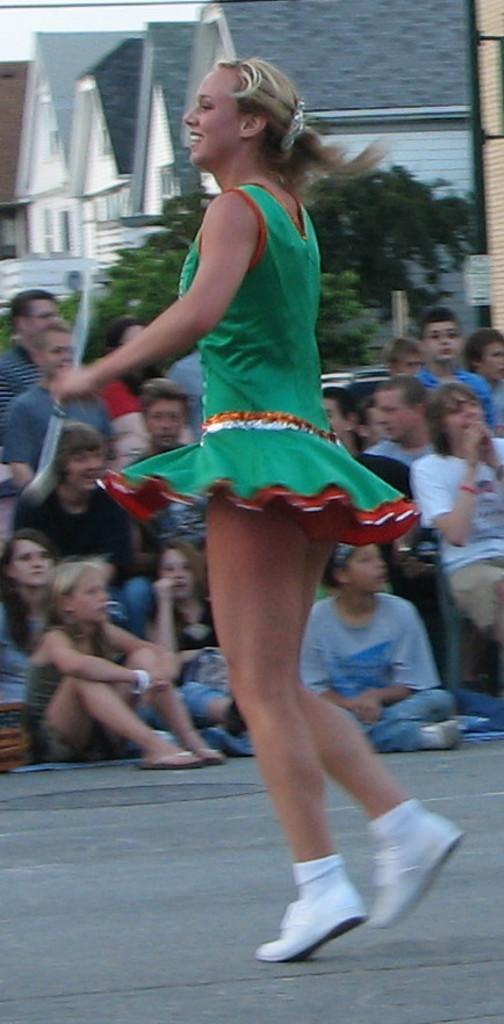Describe this image in one or two sentences. In the center of the image, we can see a lady and in the background, there are people and we can see buildings, trees and a board. At the bottom, there is a road. 